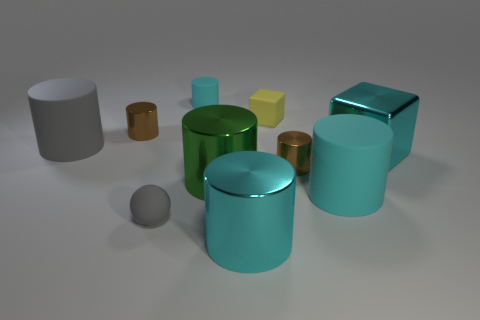Is there a green metal cylinder of the same size as the green metallic object?
Ensure brevity in your answer.  No. There is a brown thing that is behind the gray matte cylinder; is its size the same as the big cyan metallic block?
Your response must be concise. No. Is the number of large gray rubber spheres greater than the number of big gray matte objects?
Ensure brevity in your answer.  No. Is there a red rubber thing that has the same shape as the green shiny thing?
Offer a very short reply. No. The gray rubber thing behind the tiny gray object has what shape?
Give a very brief answer. Cylinder. How many big green metal things are to the left of the cube on the right side of the big cyan cylinder that is behind the gray sphere?
Offer a terse response. 1. Do the shiny cylinder that is left of the matte ball and the shiny cube have the same color?
Your response must be concise. No. What number of other objects are there of the same shape as the small cyan rubber thing?
Ensure brevity in your answer.  6. How many other objects are the same material as the big gray object?
Your answer should be compact. 4. There is a cyan cylinder behind the brown metallic object to the right of the gray sphere that is left of the big cyan cube; what is its material?
Offer a very short reply. Rubber. 